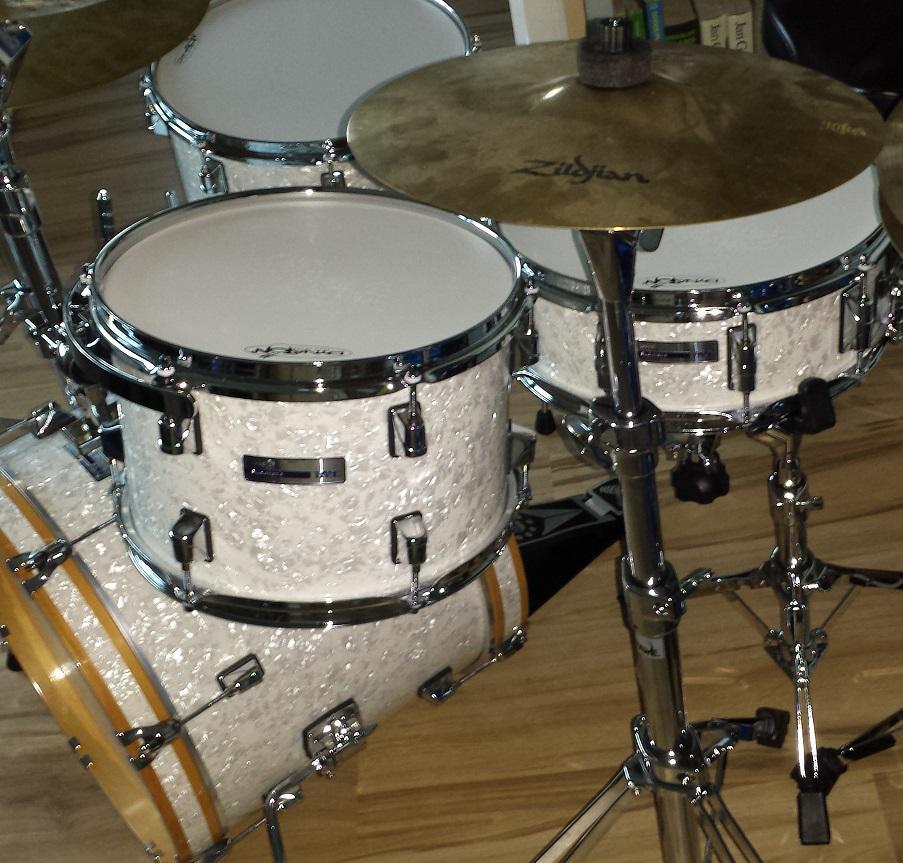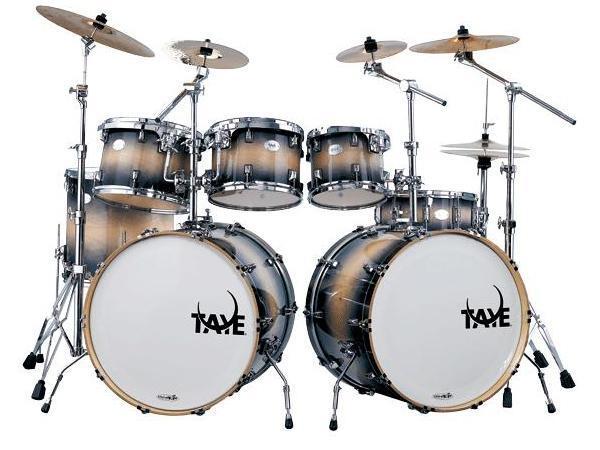The first image is the image on the left, the second image is the image on the right. Examine the images to the left and right. Is the description "Each image features a drum kit with exactly one large drum that has a white side facing outwards and is positioned between cymbals on stands." accurate? Answer yes or no. No. 